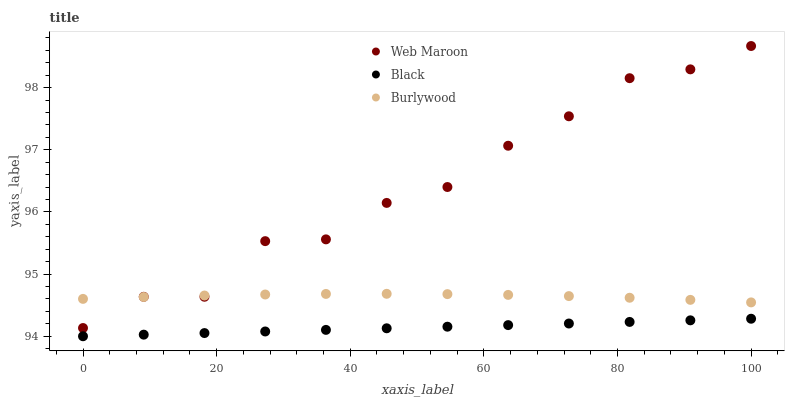Does Black have the minimum area under the curve?
Answer yes or no. Yes. Does Web Maroon have the maximum area under the curve?
Answer yes or no. Yes. Does Web Maroon have the minimum area under the curve?
Answer yes or no. No. Does Black have the maximum area under the curve?
Answer yes or no. No. Is Black the smoothest?
Answer yes or no. Yes. Is Web Maroon the roughest?
Answer yes or no. Yes. Is Web Maroon the smoothest?
Answer yes or no. No. Is Black the roughest?
Answer yes or no. No. Does Black have the lowest value?
Answer yes or no. Yes. Does Web Maroon have the lowest value?
Answer yes or no. No. Does Web Maroon have the highest value?
Answer yes or no. Yes. Does Black have the highest value?
Answer yes or no. No. Is Black less than Burlywood?
Answer yes or no. Yes. Is Burlywood greater than Black?
Answer yes or no. Yes. Does Burlywood intersect Web Maroon?
Answer yes or no. Yes. Is Burlywood less than Web Maroon?
Answer yes or no. No. Is Burlywood greater than Web Maroon?
Answer yes or no. No. Does Black intersect Burlywood?
Answer yes or no. No. 